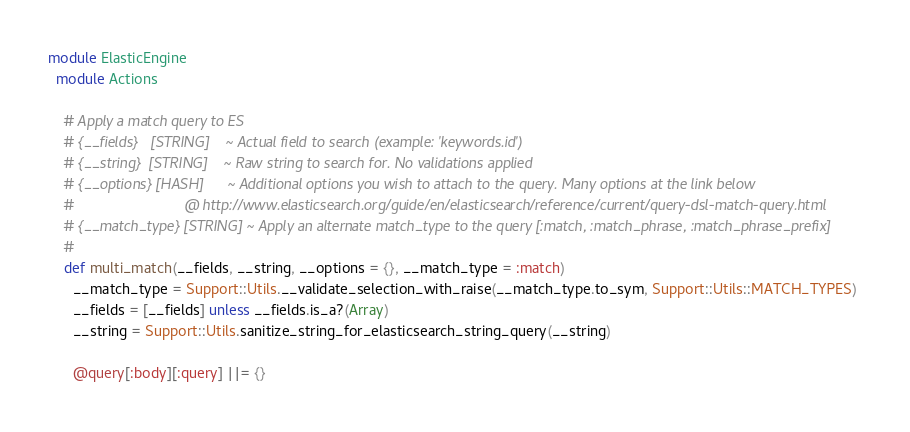<code> <loc_0><loc_0><loc_500><loc_500><_Ruby_>module ElasticEngine
  module Actions

    # Apply a match query to ES
    # {__fields}   [STRING]    ~ Actual field to search (example: 'keywords.id')
    # {__string}  [STRING]    ~ Raw string to search for. No validations applied
    # {__options} [HASH]      ~ Additional options you wish to attach to the query. Many options at the link below
    #                           @ http://www.elasticsearch.org/guide/en/elasticsearch/reference/current/query-dsl-match-query.html
    # {__match_type} [STRING] ~ Apply an alternate match_type to the query [:match, :match_phrase, :match_phrase_prefix]
    #
    def multi_match(__fields, __string, __options = {}, __match_type = :match)
      __match_type = Support::Utils.__validate_selection_with_raise(__match_type.to_sym, Support::Utils::MATCH_TYPES)
      __fields = [__fields] unless __fields.is_a?(Array)
      __string = Support::Utils.sanitize_string_for_elasticsearch_string_query(__string)
      
      @query[:body][:query] ||= {}</code> 